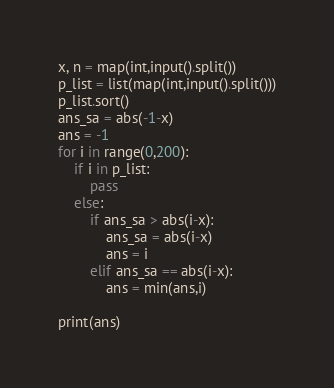Convert code to text. <code><loc_0><loc_0><loc_500><loc_500><_Python_>x, n = map(int,input().split())
p_list = list(map(int,input().split()))
p_list.sort()
ans_sa = abs(-1-x)
ans = -1
for i in range(0,200):
    if i in p_list:
        pass
    else:
        if ans_sa > abs(i-x):
            ans_sa = abs(i-x)
            ans = i
        elif ans_sa == abs(i-x):
            ans = min(ans,i)

print(ans)
</code> 